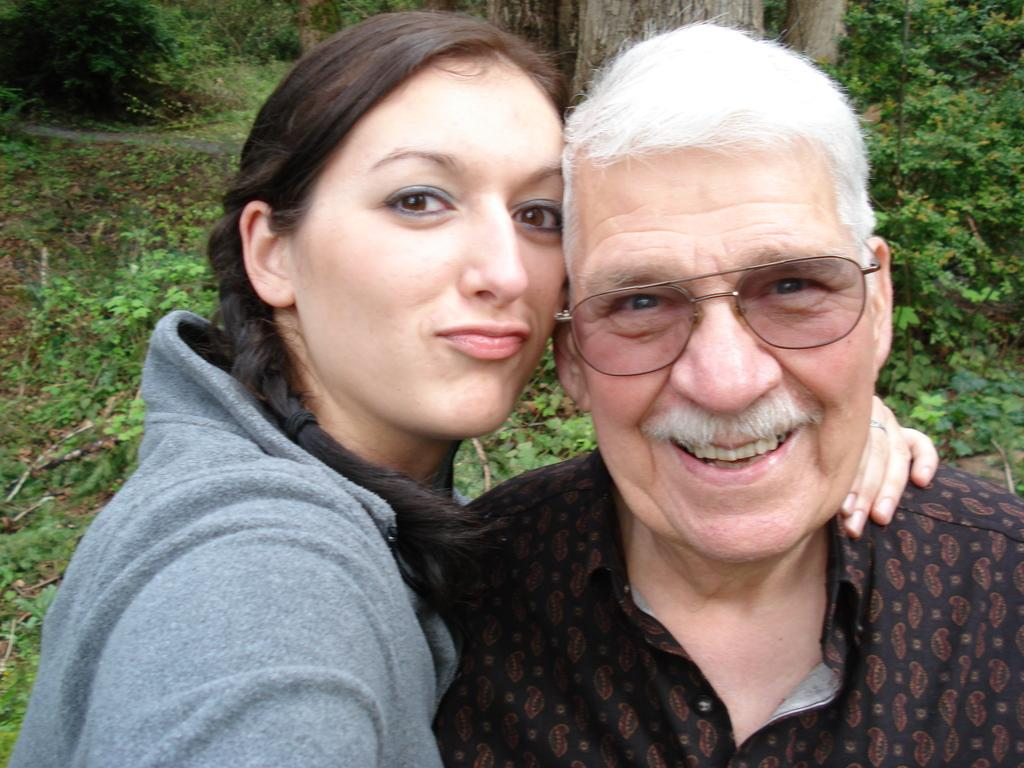How many people are in the image? There are two people in the image. What expressions do the people have? Both people are smiling. Can you describe the appearance of one of the individuals? A man in the image is wearing spectacles. What can be seen in the background of the image? Plants and trees are visible in the background of the image. How are the plants and trees positioned in the image? The plants and trees are on the ground}. What type of angle is the plane flying at in the image? There is no plane present in the image, so it is not possible to determine the angle at which it might be flying. 